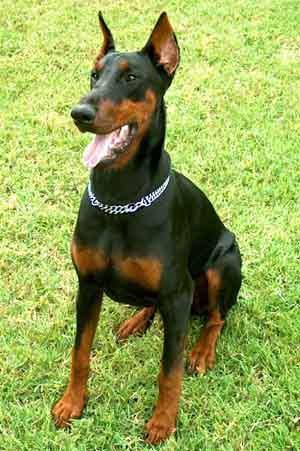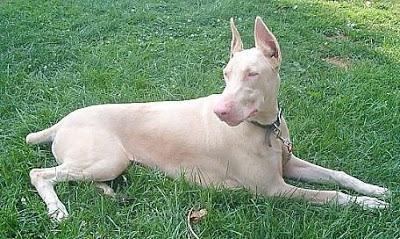The first image is the image on the left, the second image is the image on the right. For the images displayed, is the sentence "Three or more dogs are visible." factually correct? Answer yes or no. No. The first image is the image on the left, the second image is the image on the right. Considering the images on both sides, is "At least one dog is laying down." valid? Answer yes or no. Yes. 